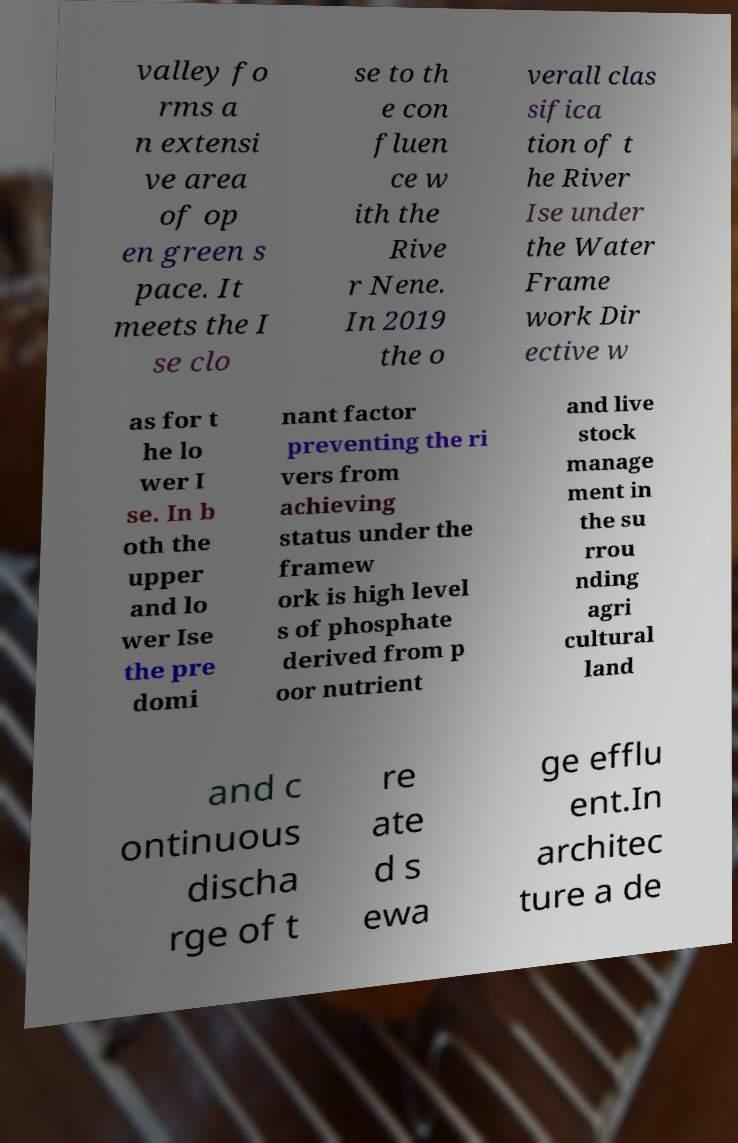There's text embedded in this image that I need extracted. Can you transcribe it verbatim? valley fo rms a n extensi ve area of op en green s pace. It meets the I se clo se to th e con fluen ce w ith the Rive r Nene. In 2019 the o verall clas sifica tion of t he River Ise under the Water Frame work Dir ective w as for t he lo wer I se. In b oth the upper and lo wer Ise the pre domi nant factor preventing the ri vers from achieving status under the framew ork is high level s of phosphate derived from p oor nutrient and live stock manage ment in the su rrou nding agri cultural land and c ontinuous discha rge of t re ate d s ewa ge efflu ent.In architec ture a de 